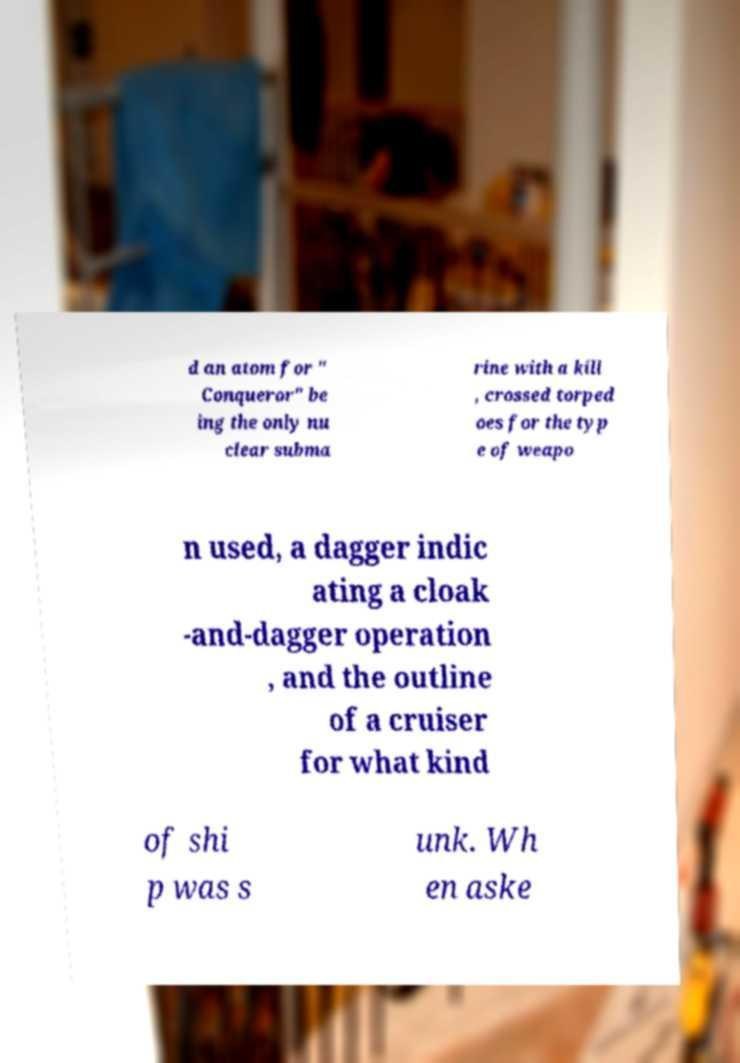Please identify and transcribe the text found in this image. d an atom for " Conqueror" be ing the only nu clear subma rine with a kill , crossed torped oes for the typ e of weapo n used, a dagger indic ating a cloak -and-dagger operation , and the outline of a cruiser for what kind of shi p was s unk. Wh en aske 